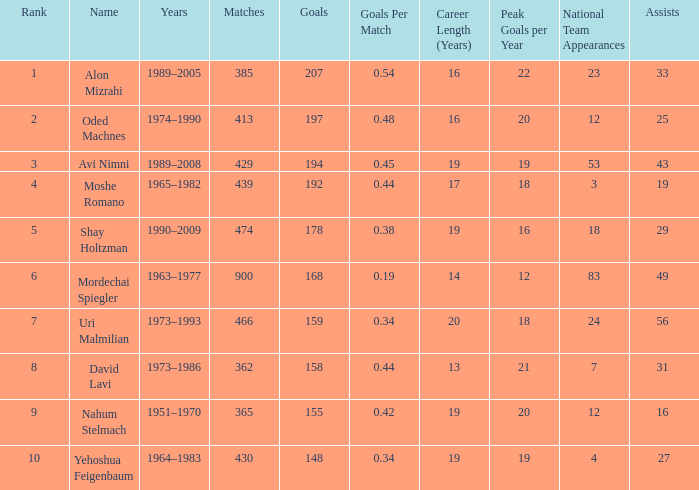What is the Rank of the player with 158 Goals in more than 362 Matches? 0.0. 